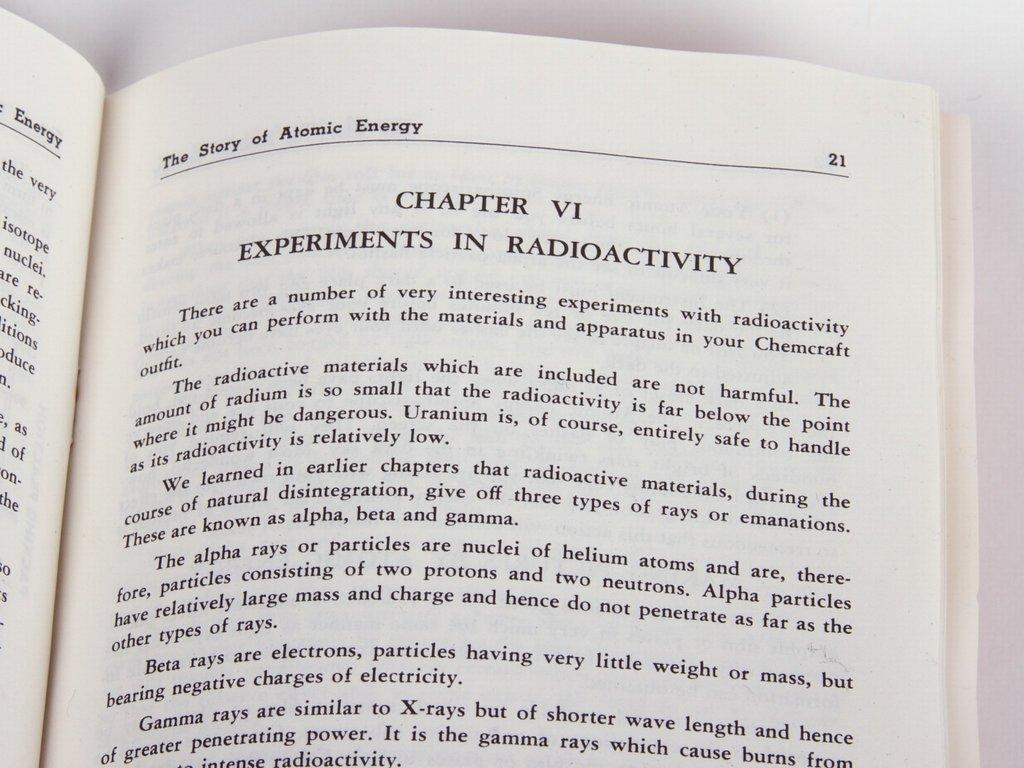What chapter is this?
Offer a terse response. Vi. What is the name of chapter vi?
Your answer should be very brief. Experiments in radioactivity. 